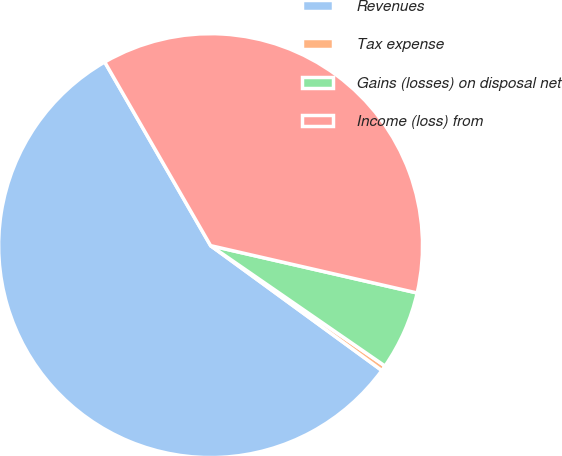Convert chart to OTSL. <chart><loc_0><loc_0><loc_500><loc_500><pie_chart><fcel>Revenues<fcel>Tax expense<fcel>Gains (losses) on disposal net<fcel>Income (loss) from<nl><fcel>56.65%<fcel>0.41%<fcel>6.03%<fcel>36.91%<nl></chart> 